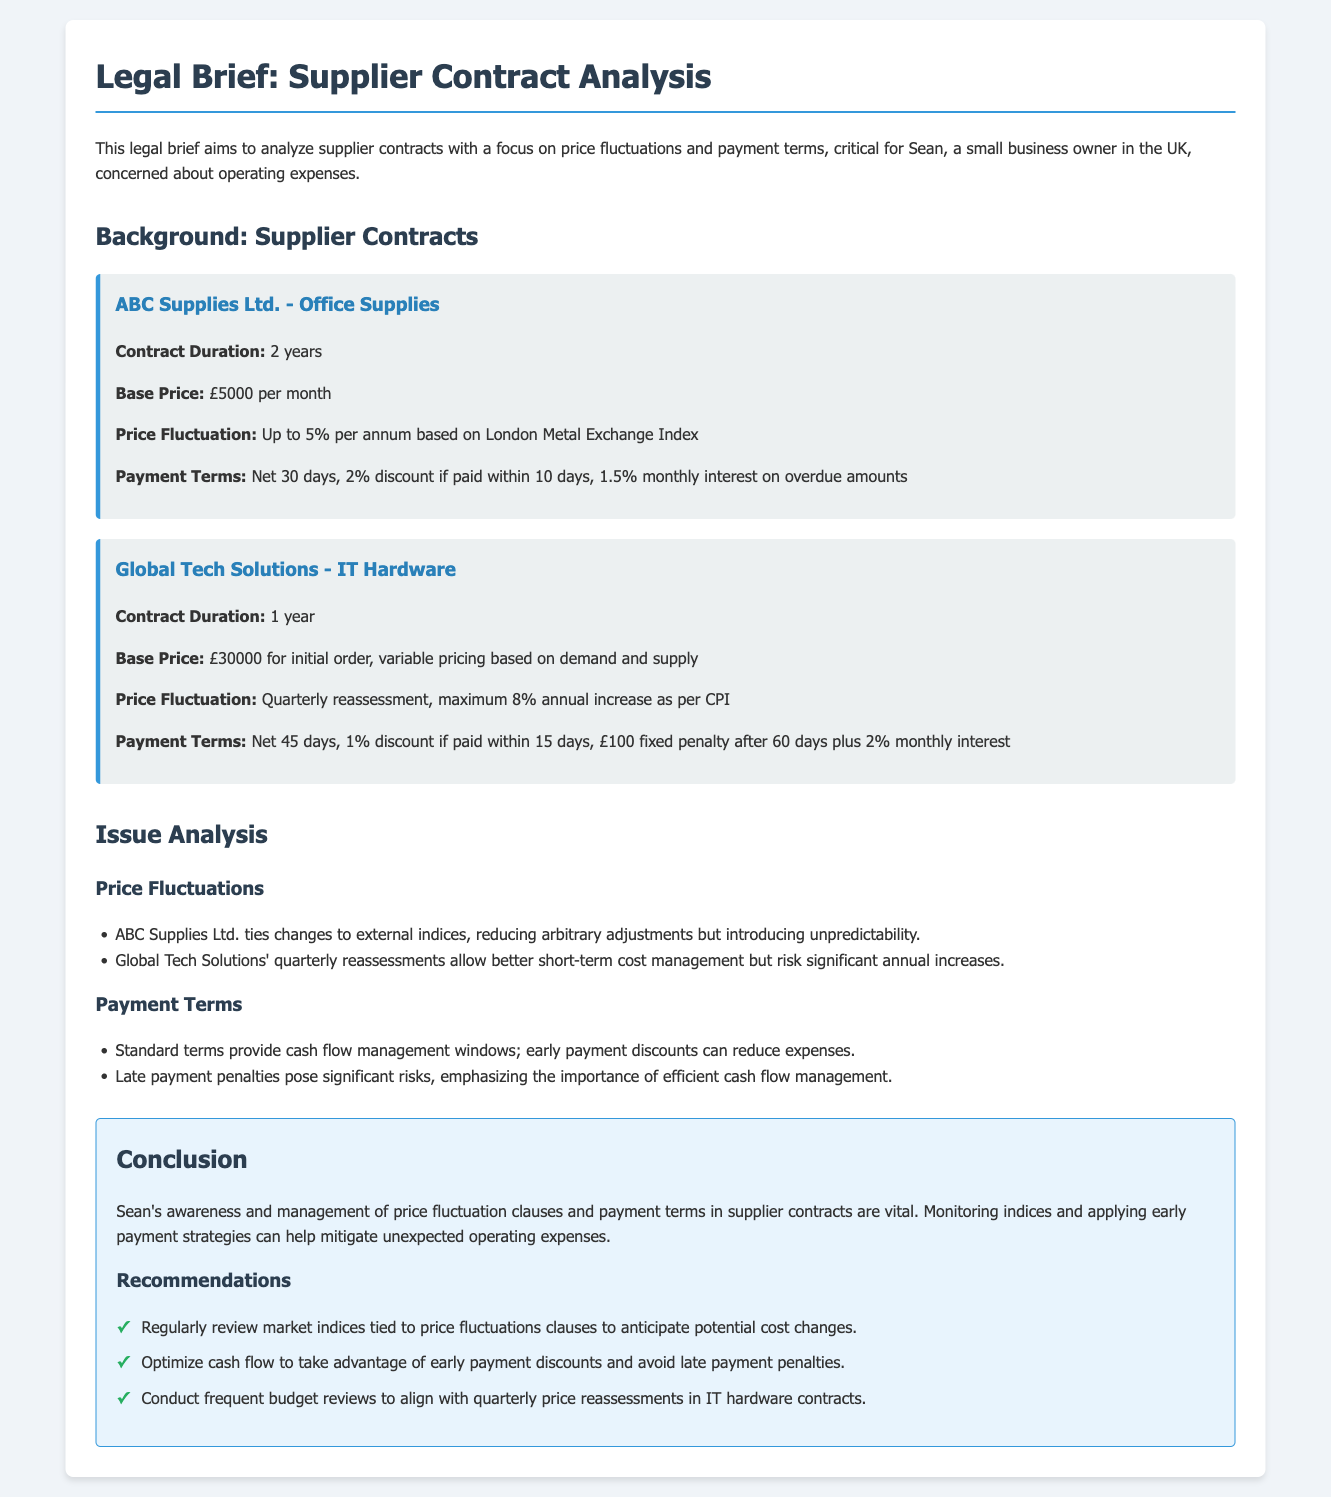What is the base price for ABC Supplies Ltd.? The base price for ABC Supplies Ltd. is specified in the document as £5000 per month.
Answer: £5000 per month What is the contract duration with Global Tech Solutions? The contract duration with Global Tech Solutions is mentioned in the document as 1 year.
Answer: 1 year What is the maximum annual increase for Global Tech Solutions? The maximum annual increase for Global Tech Solutions is indicated as 8% as per CPI.
Answer: 8% What discount is offered for early payment with ABC Supplies Ltd.? The document states that a 2% discount is provided if paid within 10 days for ABC Supplies Ltd.
Answer: 2% How often are price reassessments for Global Tech Solutions? Price reassessments for Global Tech Solutions occur quarterly according to the document.
Answer: Quarterly What is the fixed penalty for late payments with Global Tech Solutions? The document specifies that there is a £100 fixed penalty for late payments after 60 days with Global Tech Solutions.
Answer: £100 What is emphasized regarding late payment penalties in the document? It is emphasized that late payment penalties pose significant risks, highlighting efficient cash flow management.
Answer: Significant risks What should be regularly reviewed according to the recommendations? The recommendations state that market indices tied to price fluctuation clauses should be regularly reviewed.
Answer: Market indices What is the goal of optimizing cash flow as per the recommendations? The document mentions the goal of optimizing cash flow is to take advantage of early payment discounts and avoid late payment penalties.
Answer: Early payment discounts What are the consequences of not managing cash flow according to the brief? The brief states that not managing cash flow can lead to late payment penalties and unexpected operating expenses.
Answer: Late payment penalties 